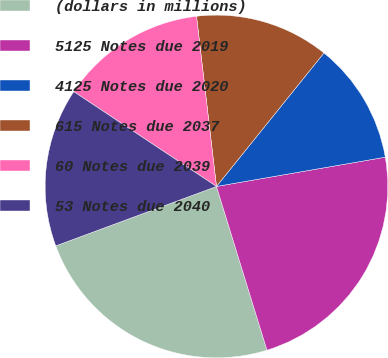Convert chart to OTSL. <chart><loc_0><loc_0><loc_500><loc_500><pie_chart><fcel>(dollars in millions)<fcel>5125 Notes due 2019<fcel>4125 Notes due 2020<fcel>615 Notes due 2037<fcel>60 Notes due 2039<fcel>53 Notes due 2040<nl><fcel>24.13%<fcel>22.97%<fcel>11.48%<fcel>12.65%<fcel>13.81%<fcel>14.97%<nl></chart> 